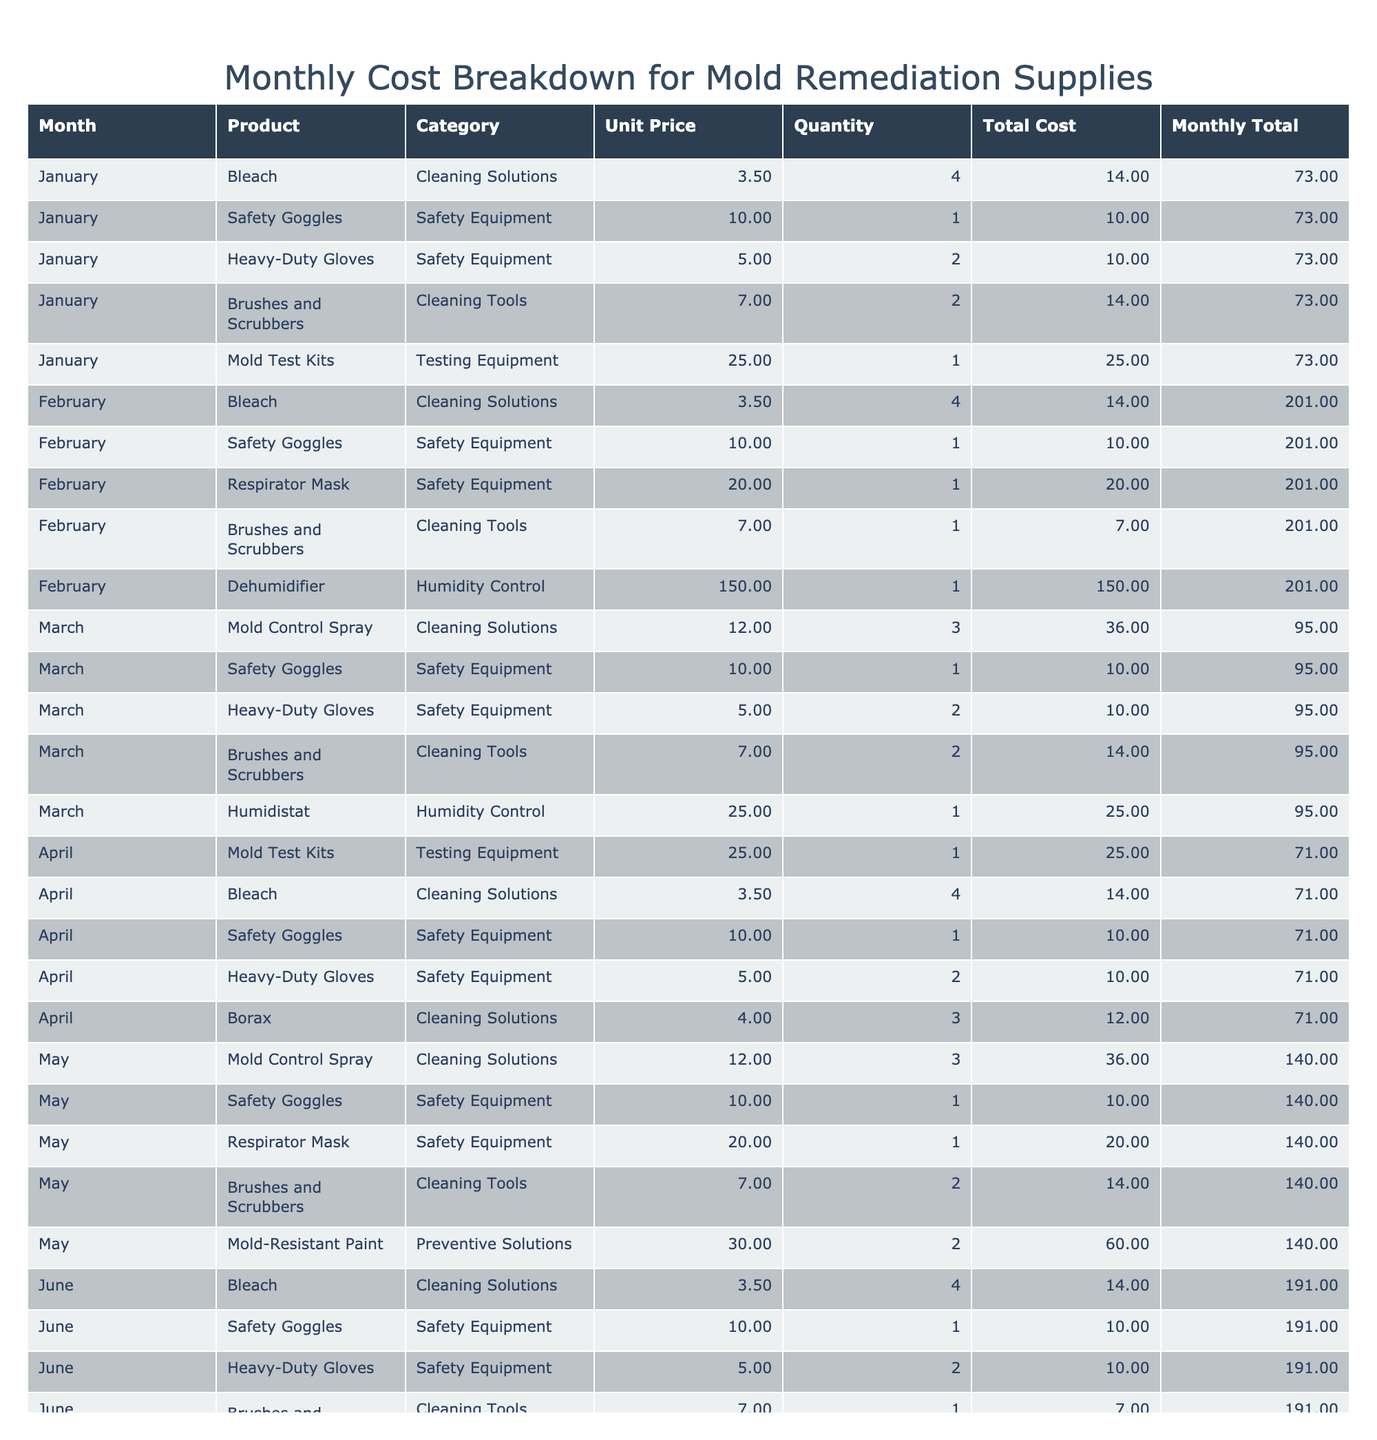What is the total cost for Mold Test Kits in April? In April, there is one entry for Mold Test Kits, and its total cost is 25.00. Therefore, the total cost for Mold Test Kits in April is directly stated in the table.
Answer: 25.00 Which month had the highest total cost for mold remediation supplies? To identify the month with the highest total cost, we sum the total costs for each month: January (73.00), February (201.00), March (95.00), April (59.00), May (140.00), June (184.00). February has the highest total cost at 201.00.
Answer: February How much did Safety Goggles cost in total over the six months? To calculate the total cost for Safety Goggles, we look at each month's entries: January (10.00), February (10.00), March (10.00), April (10.00), May (10.00), June (10.00). Summing these gives: 10.00 + 10.00 + 10.00 + 10.00 + 10.00 + 10.00 = 60.00.
Answer: 60.00 Did the total cost for dehumidifiers exceed 100.00 at any point? There are two entries for dehumidifiers: February (150.00) and June (150.00). Both are above 100.00, indicating that the costs exceeded 100.00 in both months.
Answer: Yes What is the average unit price of Cleaning Solutions based on the table provided? The unit prices for Cleaning Solutions listed are: Bleach (3.50), Mold Control Spray (12.00), and Borax (4.00). The average unit price is calculated as (3.50 + 12.00 + 3.50 + 12.00) / 4 = 7.00.
Answer: 7.00 In which month was the total cost for Brushes and Scrubbers the lowest? The costs for Brushes and Scrubbers by month are: January (14.00), February (7.00), March (14.00), April (14.00), May (14.00), June (7.00). February and June both have the lowest total cost at 7.00.
Answer: February and June What is the total number of Safety Equipment items purchased over the six months? The total quantity of Safety Equipment items purchased consists of: Safety Goggles (1 in January, 1 in February, 1 in March, 1 in April, 1 in May, 1 in June) = 6; Heavy-Duty Gloves (2 in January, 2 in March, 2 in April, 2 in May, 2 in June) = 10; Respirator Mask (1 in February, 1 in May) = 2. Adding them gives total 6 + 10 + 2 = 18.
Answer: 18 Which category had the highest cumulative cost over the six months? First, we add the total costs for each category. Cleaning Solutions total to 73.00, Safety Equipment total 60.00, Testing Equipment total 50.00, Humidity Control total 300.00, and Preventive Solutions total 60.00. Summing these shows that Humidity Control has the highest cumulative cost.
Answer: Humidity Control What was the total cost of all the supplies purchased in May? In May, the total costs of supplies are: Mold Control Spray (36.00), Safety Goggles (10.00), Respirator Mask (20.00), Brushes and Scrubbers (14.00), Mold-Resistant Paint (60.00). Adding these gives a total of 36.00 + 10.00 + 20.00 + 14.00 + 60.00 = 150.00.
Answer: 150.00 